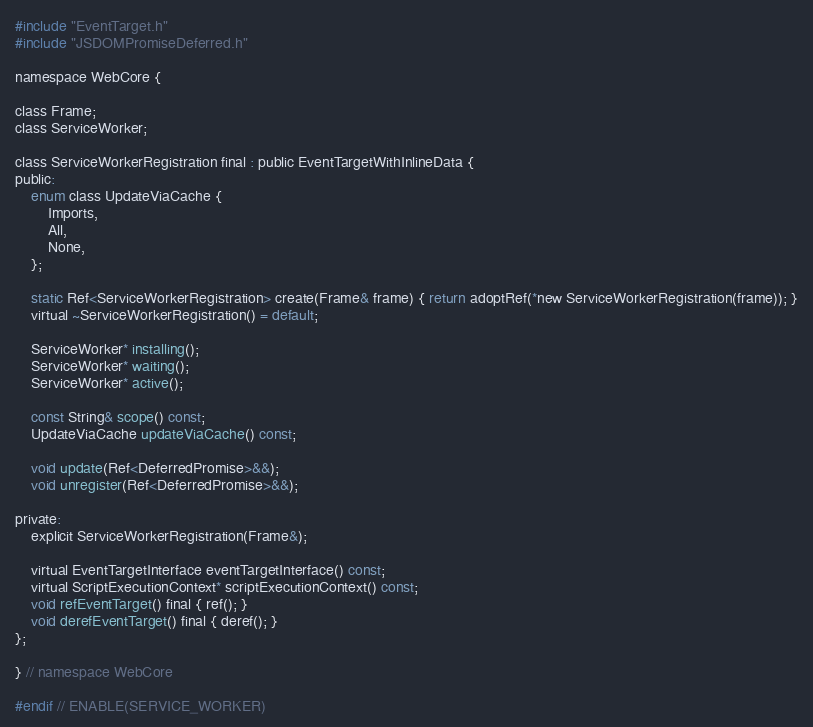Convert code to text. <code><loc_0><loc_0><loc_500><loc_500><_C_>#include "EventTarget.h"
#include "JSDOMPromiseDeferred.h"

namespace WebCore {

class Frame;
class ServiceWorker;

class ServiceWorkerRegistration final : public EventTargetWithInlineData {
public:
    enum class UpdateViaCache {
        Imports,
        All,
        None,
    };

    static Ref<ServiceWorkerRegistration> create(Frame& frame) { return adoptRef(*new ServiceWorkerRegistration(frame)); }
    virtual ~ServiceWorkerRegistration() = default;

    ServiceWorker* installing();
    ServiceWorker* waiting();
    ServiceWorker* active();

    const String& scope() const;
    UpdateViaCache updateViaCache() const;

    void update(Ref<DeferredPromise>&&);
    void unregister(Ref<DeferredPromise>&&);

private:
    explicit ServiceWorkerRegistration(Frame&);

    virtual EventTargetInterface eventTargetInterface() const;
    virtual ScriptExecutionContext* scriptExecutionContext() const;
    void refEventTarget() final { ref(); }
    void derefEventTarget() final { deref(); }
};

} // namespace WebCore

#endif // ENABLE(SERVICE_WORKER)
</code> 